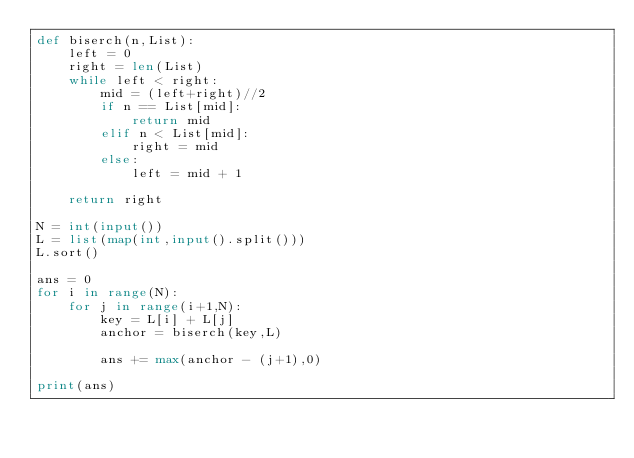<code> <loc_0><loc_0><loc_500><loc_500><_Python_>def biserch(n,List):
    left = 0
    right = len(List)
    while left < right:
        mid = (left+right)//2
        if n == List[mid]:
            return mid
        elif n < List[mid]:
            right = mid
        else:
            left = mid + 1
    
    return right
    
N = int(input())
L = list(map(int,input().split()))
L.sort()

ans = 0
for i in range(N):
    for j in range(i+1,N):
        key = L[i] + L[j]
        anchor = biserch(key,L)
        
        ans += max(anchor - (j+1),0)

print(ans)</code> 